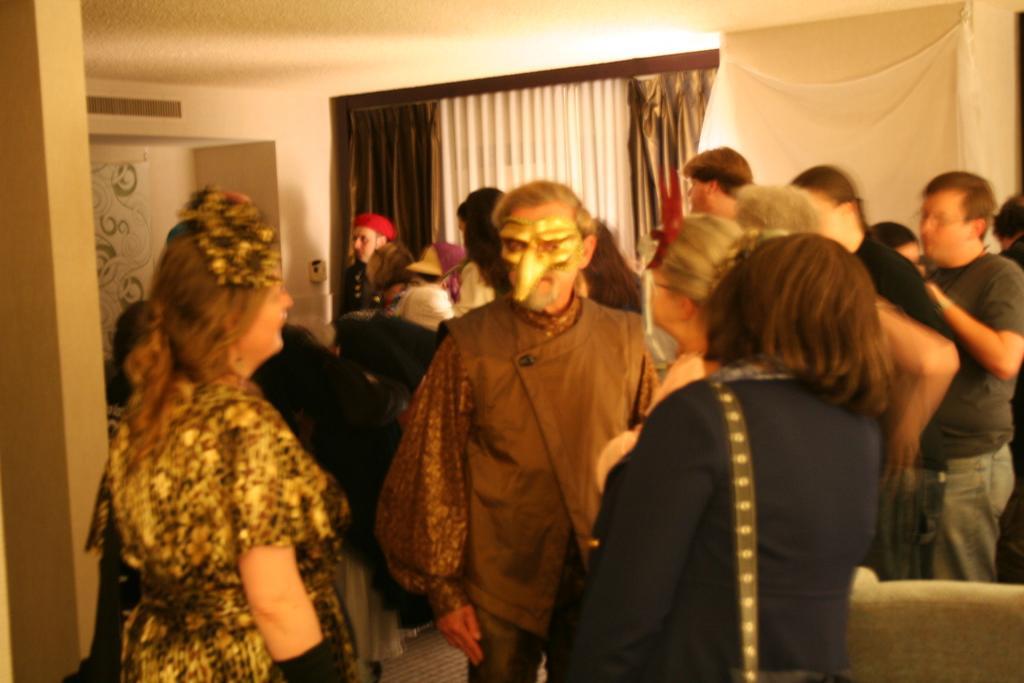Can you describe this image briefly? This image is taken indoors. In the background there are a few walls, a window and curtains. In the middle of the image a few people are standing on the floor. On the right side of the image there is an empty chair. 